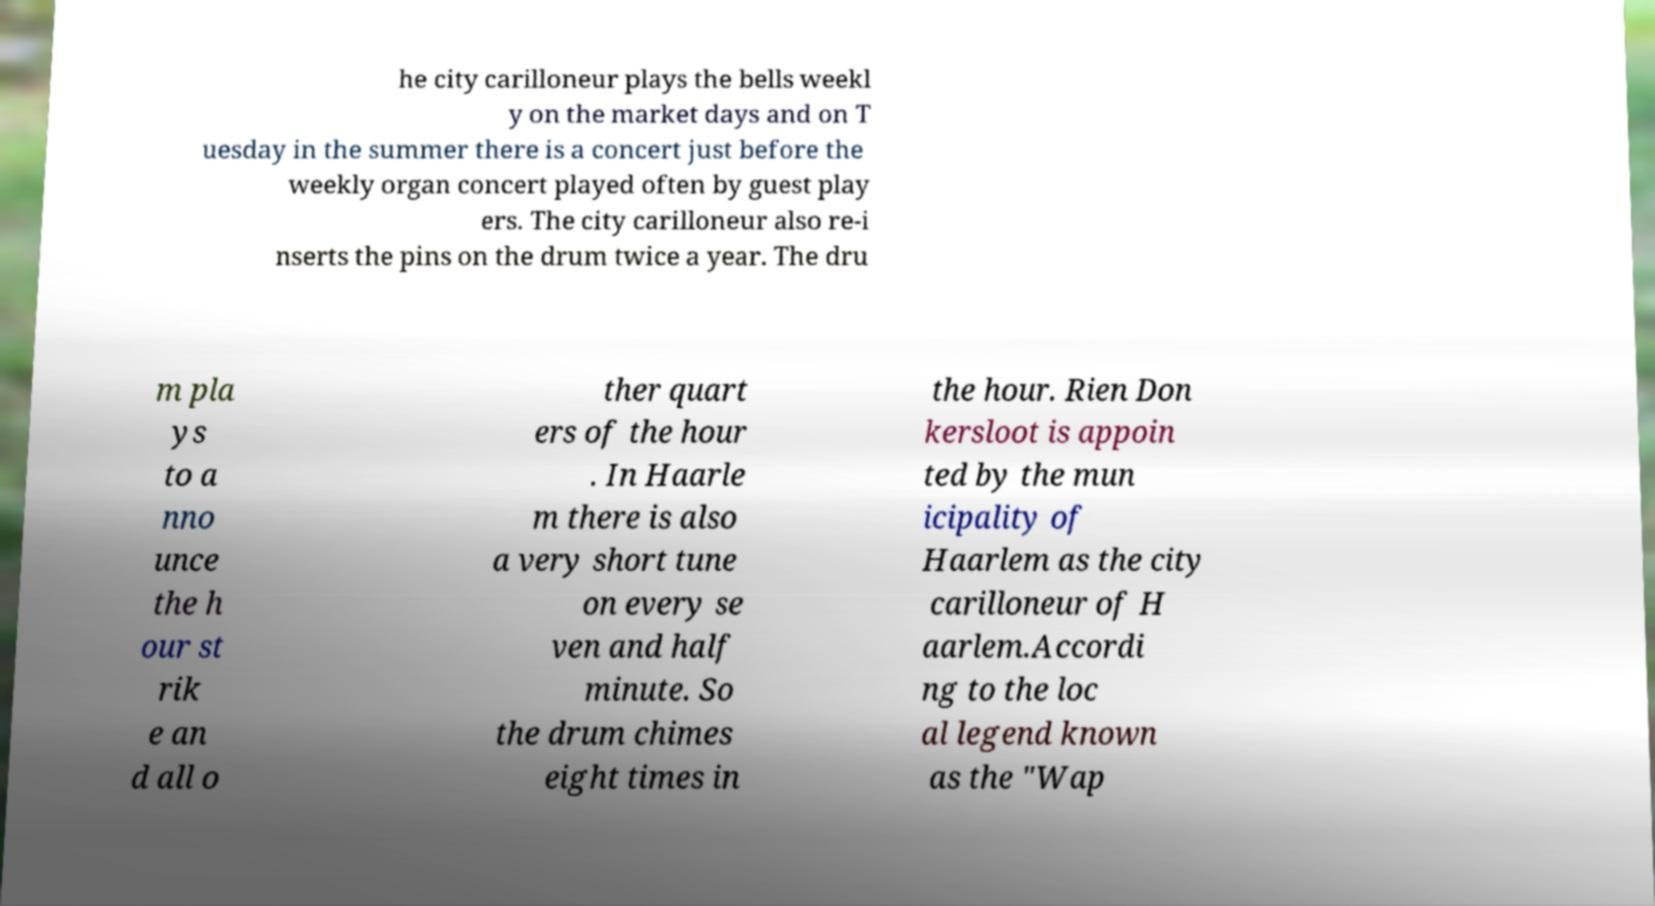There's text embedded in this image that I need extracted. Can you transcribe it verbatim? he city carilloneur plays the bells weekl y on the market days and on T uesday in the summer there is a concert just before the weekly organ concert played often by guest play ers. The city carilloneur also re-i nserts the pins on the drum twice a year. The dru m pla ys to a nno unce the h our st rik e an d all o ther quart ers of the hour . In Haarle m there is also a very short tune on every se ven and half minute. So the drum chimes eight times in the hour. Rien Don kersloot is appoin ted by the mun icipality of Haarlem as the city carilloneur of H aarlem.Accordi ng to the loc al legend known as the "Wap 